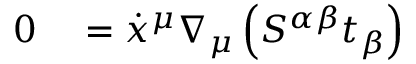<formula> <loc_0><loc_0><loc_500><loc_500>\begin{array} { r l } { 0 } & = \dot { x } ^ { \mu } \nabla _ { \mu } \left ( S ^ { \alpha \beta } t _ { \beta } \right ) } \end{array}</formula> 